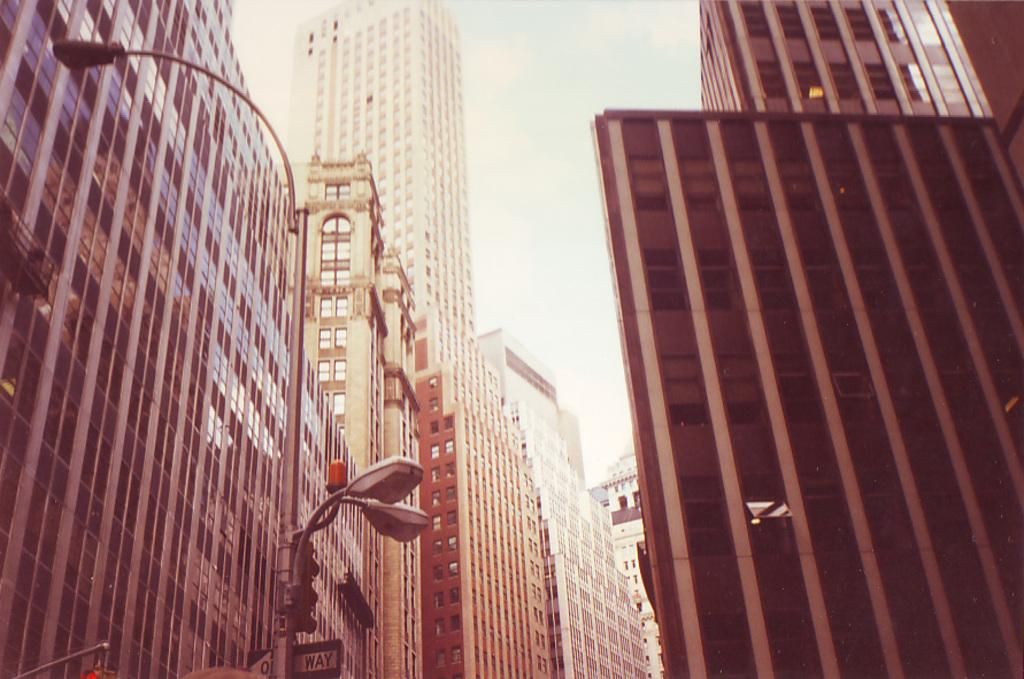<image>
Describe the image concisely. Near the tall buildings a post has a sign that reads one way. 